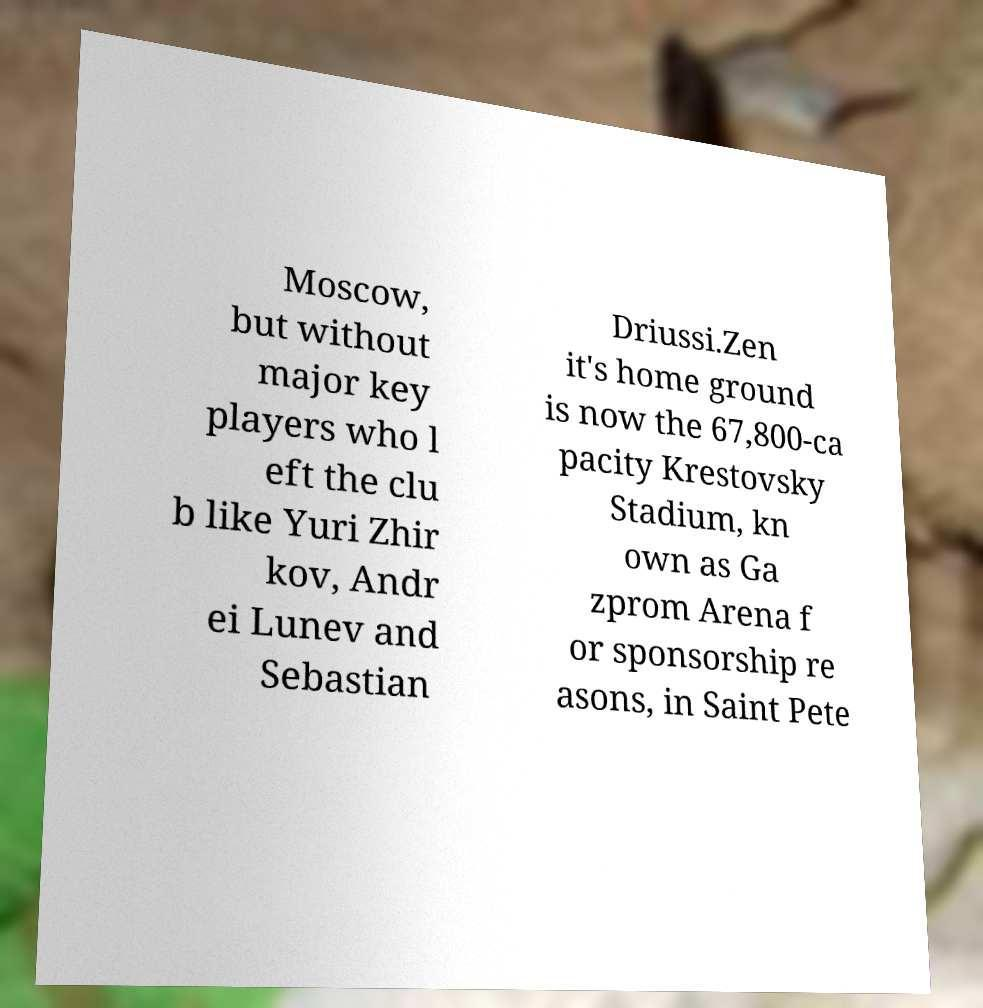Could you assist in decoding the text presented in this image and type it out clearly? Moscow, but without major key players who l eft the clu b like Yuri Zhir kov, Andr ei Lunev and Sebastian Driussi.Zen it's home ground is now the 67,800-ca pacity Krestovsky Stadium, kn own as Ga zprom Arena f or sponsorship re asons, in Saint Pete 